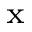<formula> <loc_0><loc_0><loc_500><loc_500>^ { x }</formula> 